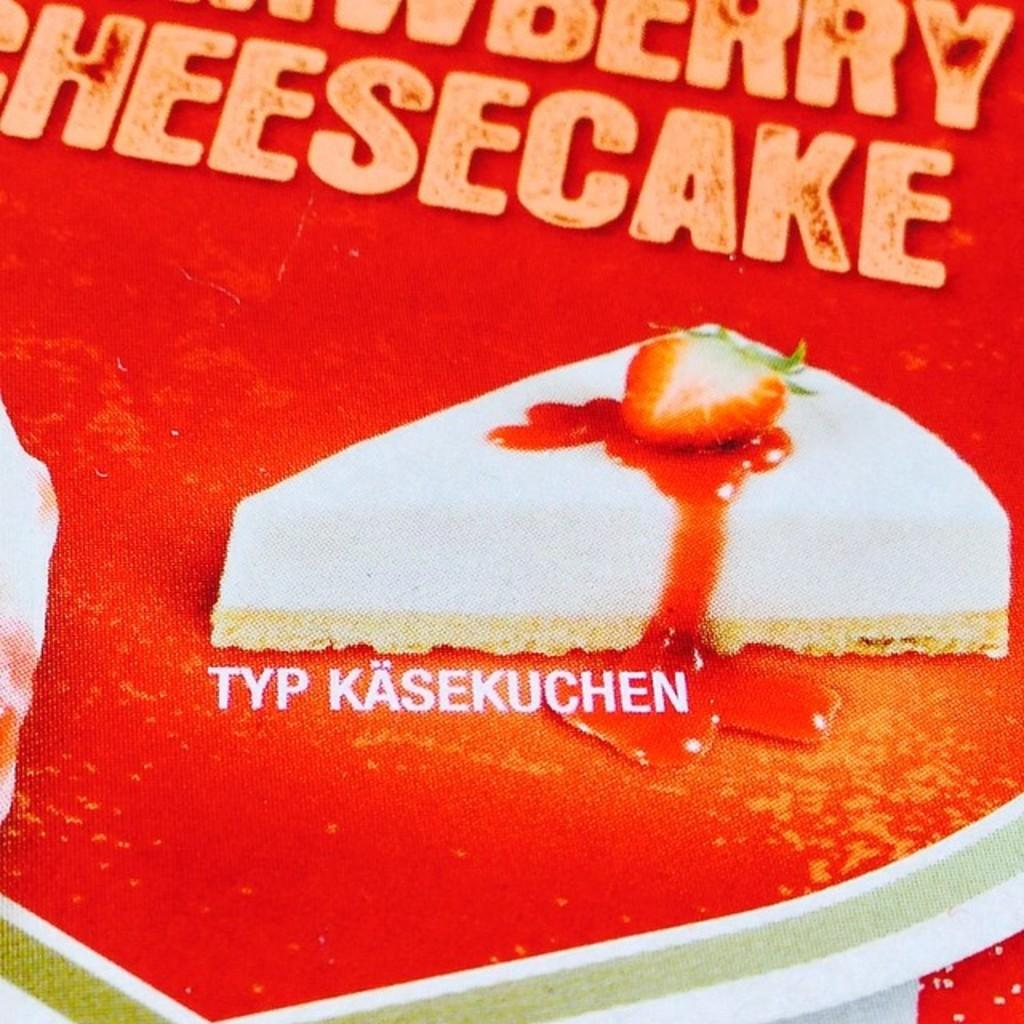What type of publication is visible in the image? There is a part of a magazine in the image. What is the color of the magazine? The magazine is red in color. What is the main topic or feature of the magazine? The name "cheese cake" is visible on the magazine. What type of image is present on the magazine? There is an image of a strawberry slice on the magazine. Where is the faucet located in the image? There is no faucet present in the image. What type of knife is shown in the image? There is no knife present in the image. 